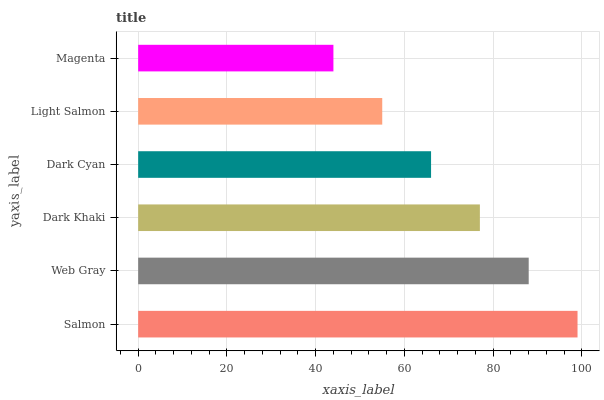Is Magenta the minimum?
Answer yes or no. Yes. Is Salmon the maximum?
Answer yes or no. Yes. Is Web Gray the minimum?
Answer yes or no. No. Is Web Gray the maximum?
Answer yes or no. No. Is Salmon greater than Web Gray?
Answer yes or no. Yes. Is Web Gray less than Salmon?
Answer yes or no. Yes. Is Web Gray greater than Salmon?
Answer yes or no. No. Is Salmon less than Web Gray?
Answer yes or no. No. Is Dark Khaki the high median?
Answer yes or no. Yes. Is Dark Cyan the low median?
Answer yes or no. Yes. Is Light Salmon the high median?
Answer yes or no. No. Is Web Gray the low median?
Answer yes or no. No. 